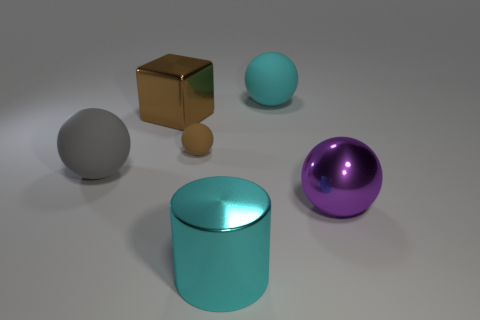Subtract 2 spheres. How many spheres are left? 2 Subtract all large balls. How many balls are left? 1 Subtract all cyan balls. How many balls are left? 3 Subtract all cyan balls. Subtract all yellow blocks. How many balls are left? 3 Add 2 big balls. How many objects exist? 8 Add 4 large cyan matte spheres. How many large cyan matte spheres are left? 5 Add 5 big green rubber balls. How many big green rubber balls exist? 5 Subtract 1 purple spheres. How many objects are left? 5 Subtract all cylinders. How many objects are left? 5 Subtract all tiny objects. Subtract all large shiny things. How many objects are left? 2 